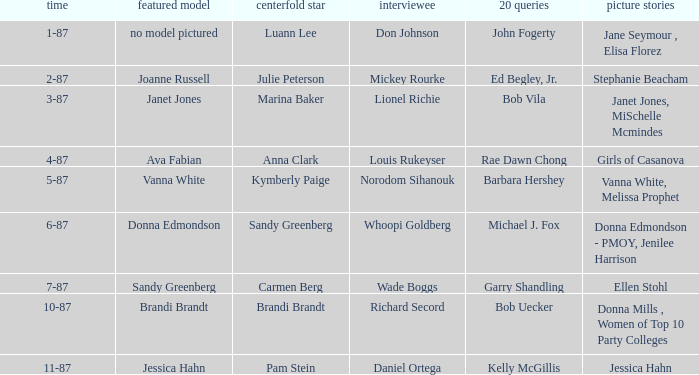Who was the on the cover when Bob Vila did the 20 Questions? Janet Jones. 